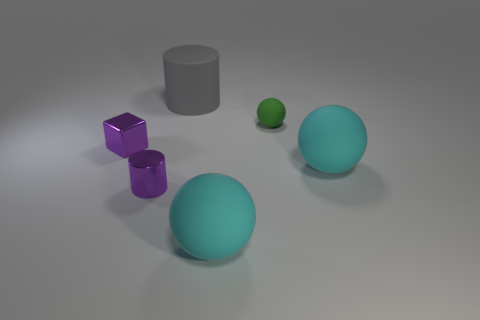What is the size of the cylinder that is the same color as the tiny cube?
Ensure brevity in your answer.  Small. The green object that is the same material as the gray thing is what shape?
Provide a short and direct response. Sphere. What is the color of the tiny thing to the left of the cylinder that is in front of the large gray matte cylinder?
Your answer should be very brief. Purple. Does the small sphere have the same color as the large matte cylinder?
Your answer should be very brief. No. There is a cyan sphere that is in front of the cylinder in front of the gray cylinder; what is its material?
Provide a short and direct response. Rubber. There is a small purple object that is the same shape as the gray thing; what material is it?
Your answer should be compact. Metal. There is a big cyan thing that is behind the purple metallic thing that is right of the purple cube; is there a tiny matte thing that is in front of it?
Offer a very short reply. No. What number of other objects are there of the same color as the small block?
Keep it short and to the point. 1. How many objects are both on the right side of the tiny metallic block and on the left side of the large gray thing?
Your answer should be very brief. 1. The gray rubber thing has what shape?
Keep it short and to the point. Cylinder. 